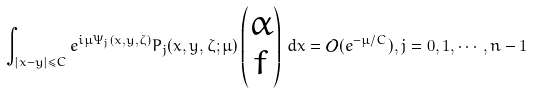<formula> <loc_0><loc_0><loc_500><loc_500>\int _ { | x - y | \leq C } e ^ { i \mu \Psi _ { j } ( x , y , \zeta ) } P _ { j } ( x , y , \zeta ; \mu ) \begin{pmatrix} \alpha \\ f \end{pmatrix} \, d x = \mathcal { O } ( e ^ { - \mu / C } ) , j = 0 , 1 , \cdots , n - 1</formula> 